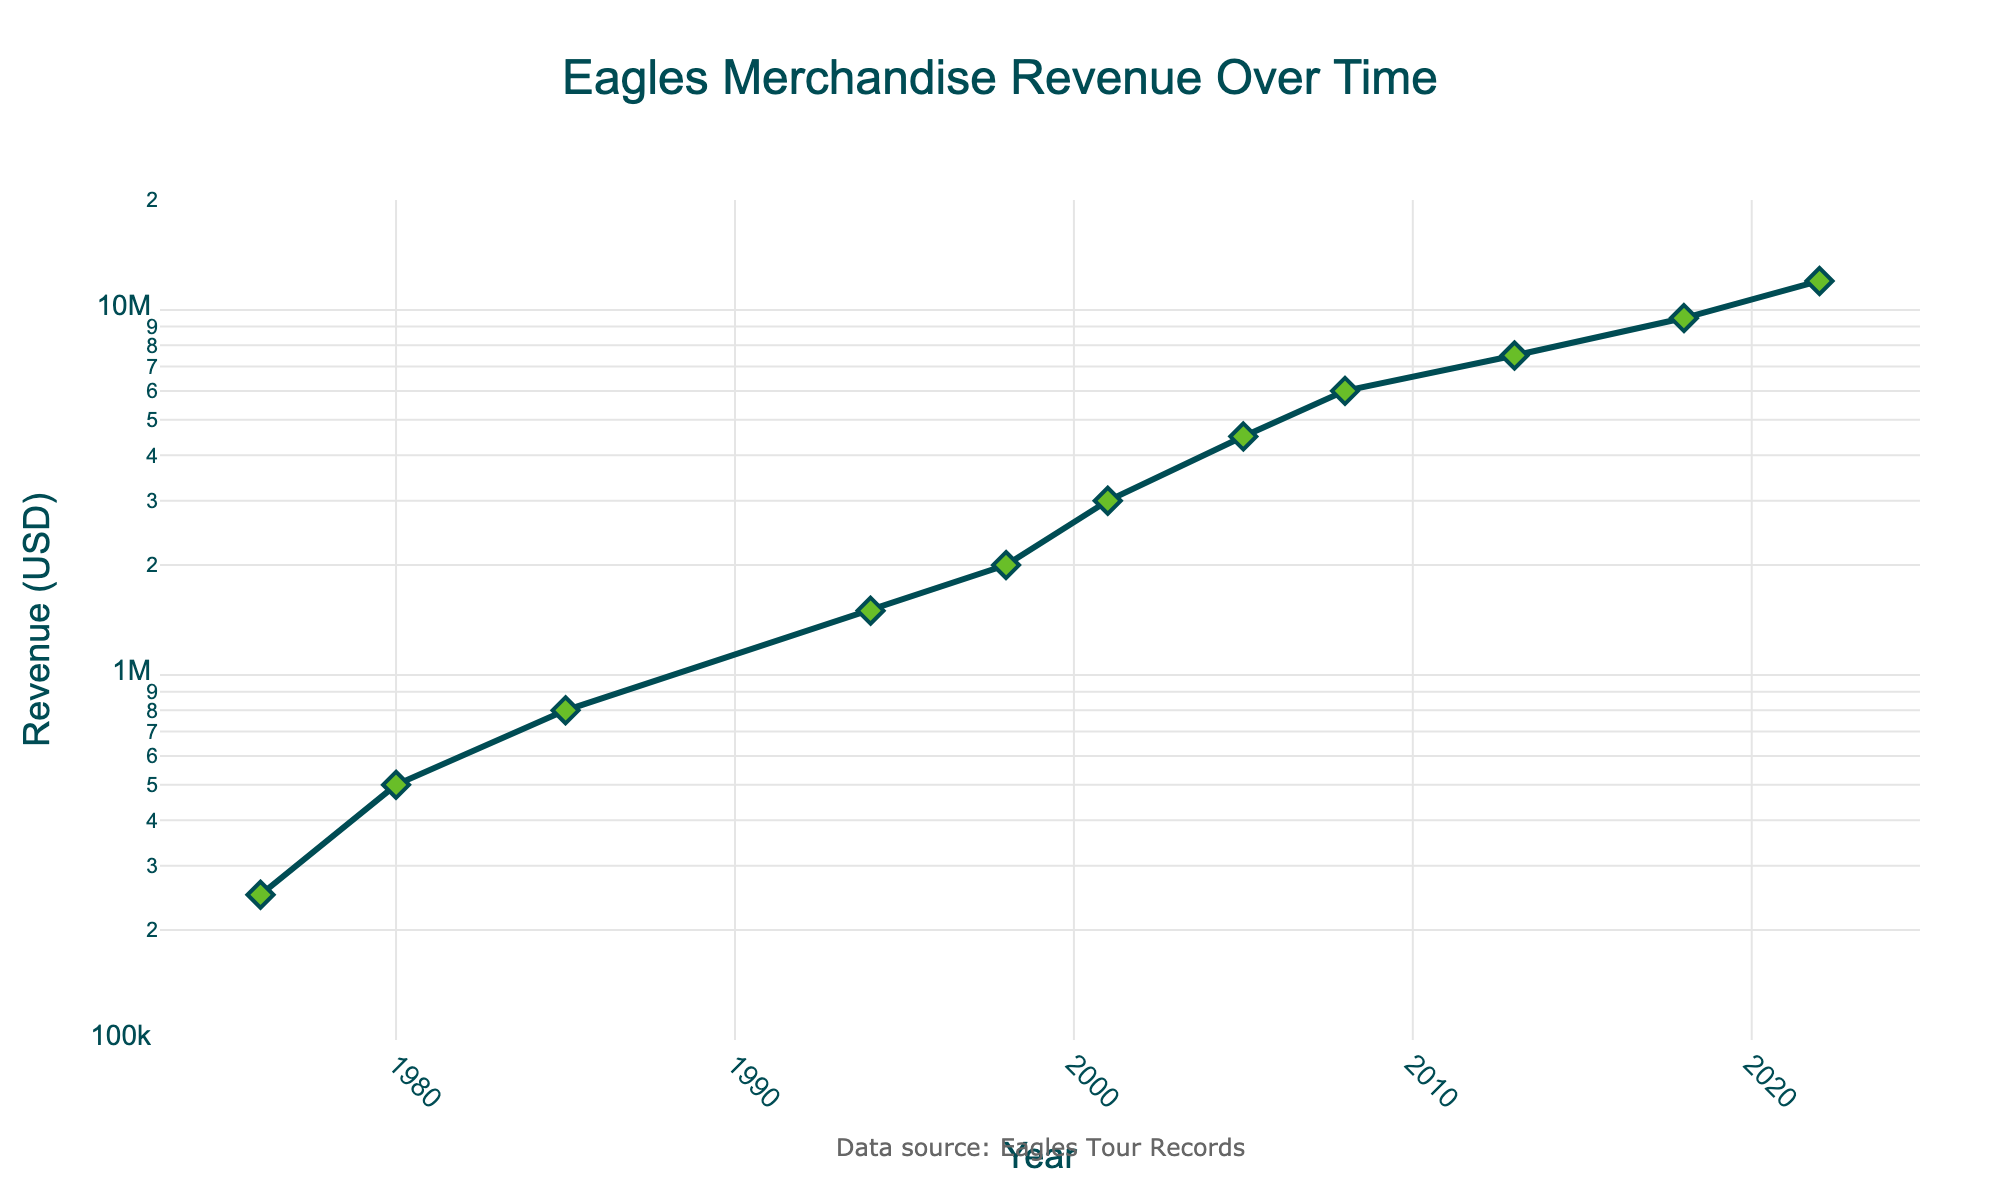What is the title of the figure? The title of the figure is prominently at the top and reads "Eagles Merchandise Revenue Over Time."
Answer: Eagles Merchandise Revenue Over Time How many data points are shown in the figure? The year-marked data points are represented with diamond markers, revealing a total of 11 points from 1976 to 2022.
Answer: 11 What is the lowest revenue value displayed, and in which year was it recorded? The lowest revenue value is located at the start of the plot and corresponds to the year 1976, showing $250,000.
Answer: $250,000 in 1976 Which year had the highest revenue from merchandise sales according to the plot? The highest point on the y-axis corresponds to the year 2022, indicating the peak revenue of $12,000,000.
Answer: 2022 By what factor did the merchandise revenue increase from 1976 to 2022? The revenue in 1976 was $250,000 and increased to $12,000,000 in 2022. The factor of increase is calculated by dividing the latter by the former: $12,000,000 / $250,000 = 48.
Answer: 48 Between which consecutive years was the largest increase in revenue observed? To find the largest increase, inspect the vertical distance between consecutive points. From 2001 ($3,000,000) to 2005 ($4,500,000), the increase is $1,500,000, which visually appears as the greatest increase.
Answer: 2001 to 2005 What's the average annual increase in revenue between the years 1985 and 1994? Revenue in 1985 was $800,000 and in 1994 it was $1,500,000. The difference is $1,500,000 - $800,000 = $700,000 over 9 years. The average increase per year is $700,000 / 9 = $77,777.78.
Answer: $77,777.78 In what range does the y-axis data fall in the plot? The y-axis is on a log scale ranging from just over $100,000 to $20,000,000, encompassing the revenue values shown in the figure.
Answer: Around $100,000 to $20,000,000 During which period did the Eagles’ merchandise revenue first exceed $1,000,000? By following the line graph, the merchandise revenue surpasses $1,000,000 for the first time in 1994.
Answer: 1994 What is the median merchandise revenue over the years? To find the median of 11 values, first organize: $250,000, $500,000, $800,000, $1,500,000, $2,000,000, $3,000,000, $4,500,000, $6,000,000, $7,500,000, $9,500,000, $12,000,000. The middle value (6th) is $3,000,000.
Answer: $3,000,000 